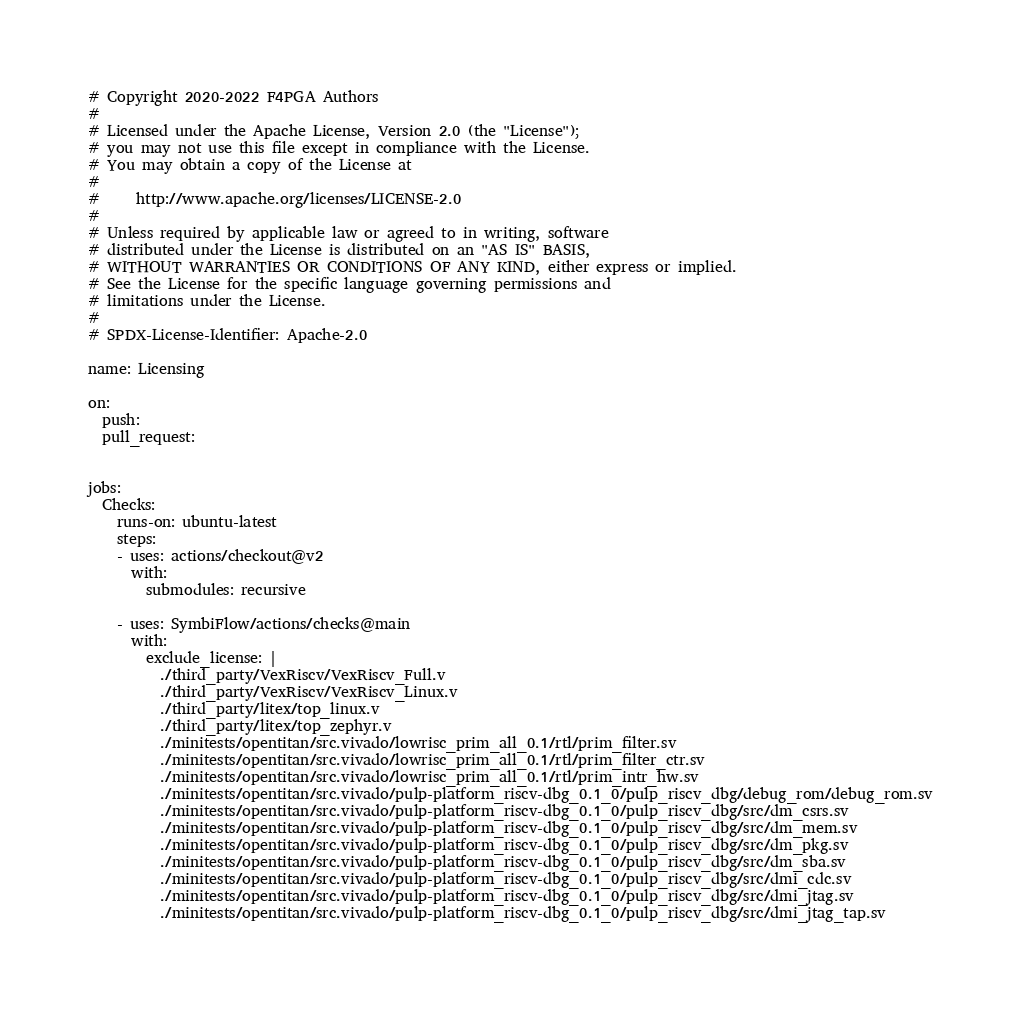<code> <loc_0><loc_0><loc_500><loc_500><_YAML_># Copyright 2020-2022 F4PGA Authors
#
# Licensed under the Apache License, Version 2.0 (the "License");
# you may not use this file except in compliance with the License.
# You may obtain a copy of the License at
#
#     http://www.apache.org/licenses/LICENSE-2.0
#
# Unless required by applicable law or agreed to in writing, software
# distributed under the License is distributed on an "AS IS" BASIS,
# WITHOUT WARRANTIES OR CONDITIONS OF ANY KIND, either express or implied.
# See the License for the specific language governing permissions and
# limitations under the License.
#
# SPDX-License-Identifier: Apache-2.0

name: Licensing

on:
  push:
  pull_request:


jobs:
  Checks:
    runs-on: ubuntu-latest
    steps:
    - uses: actions/checkout@v2
      with:
        submodules: recursive

    - uses: SymbiFlow/actions/checks@main
      with:
        exclude_license: |
          ./third_party/VexRiscv/VexRiscv_Full.v
          ./third_party/VexRiscv/VexRiscv_Linux.v
          ./third_party/litex/top_linux.v
          ./third_party/litex/top_zephyr.v
          ./minitests/opentitan/src.vivado/lowrisc_prim_all_0.1/rtl/prim_filter.sv
          ./minitests/opentitan/src.vivado/lowrisc_prim_all_0.1/rtl/prim_filter_ctr.sv
          ./minitests/opentitan/src.vivado/lowrisc_prim_all_0.1/rtl/prim_intr_hw.sv
          ./minitests/opentitan/src.vivado/pulp-platform_riscv-dbg_0.1_0/pulp_riscv_dbg/debug_rom/debug_rom.sv
          ./minitests/opentitan/src.vivado/pulp-platform_riscv-dbg_0.1_0/pulp_riscv_dbg/src/dm_csrs.sv
          ./minitests/opentitan/src.vivado/pulp-platform_riscv-dbg_0.1_0/pulp_riscv_dbg/src/dm_mem.sv
          ./minitests/opentitan/src.vivado/pulp-platform_riscv-dbg_0.1_0/pulp_riscv_dbg/src/dm_pkg.sv
          ./minitests/opentitan/src.vivado/pulp-platform_riscv-dbg_0.1_0/pulp_riscv_dbg/src/dm_sba.sv
          ./minitests/opentitan/src.vivado/pulp-platform_riscv-dbg_0.1_0/pulp_riscv_dbg/src/dmi_cdc.sv
          ./minitests/opentitan/src.vivado/pulp-platform_riscv-dbg_0.1_0/pulp_riscv_dbg/src/dmi_jtag.sv
          ./minitests/opentitan/src.vivado/pulp-platform_riscv-dbg_0.1_0/pulp_riscv_dbg/src/dmi_jtag_tap.sv

</code> 